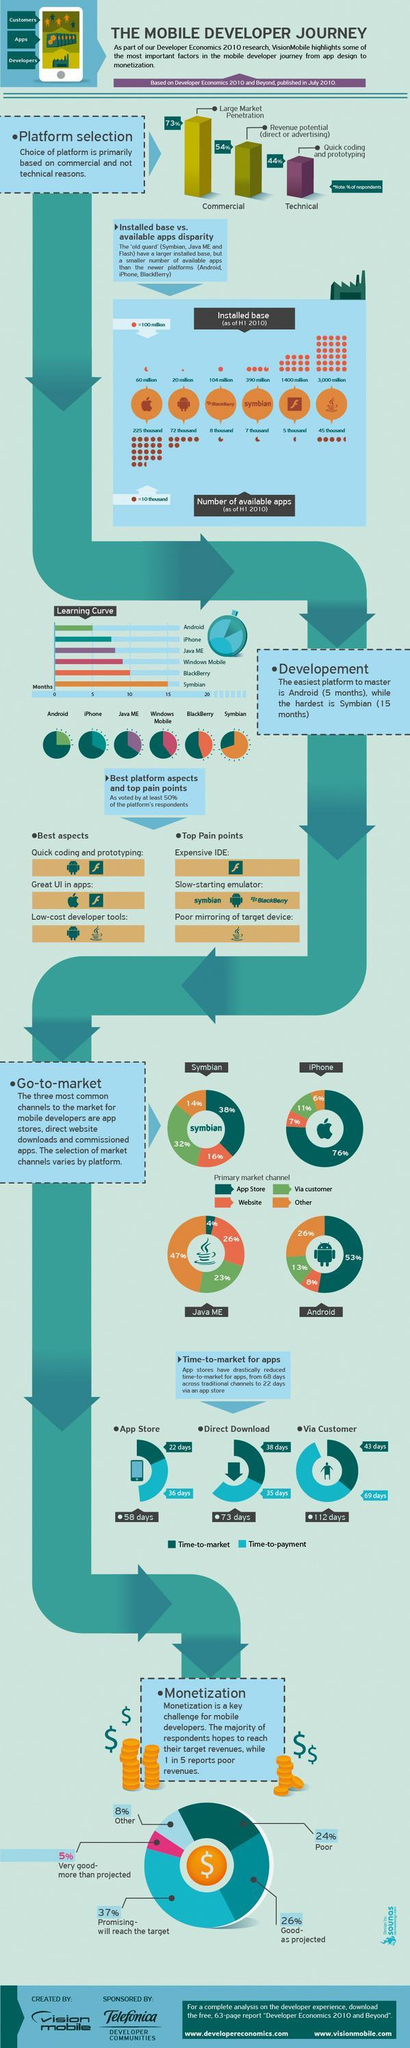What is the top pain point with respect to Flash platform?
Answer the question with a short phrase. Expensive IDE Which primary market channel is used by 26% of Java ME developers? Website What is the Time-to-payment for apps through App Store? 36 days Which of these platforms takes longer time to master - iPhone, Java ME or Windows Mobile? Windows Mobile How many apps are available for Android platform as of H1 2010? 72 thousand Which platform supports low-cost developer tools - Windows Mobile, Android or iPhone? Android What is the Time-to-market for apps via direct download? 38 days App Store is the primary market channel for what percent of Android developers? 53% What is listed as the best aspects of Apple iPhone platform? Great UI in apps What is the number of available apps for Java as of H1 2010? 45 thousand 